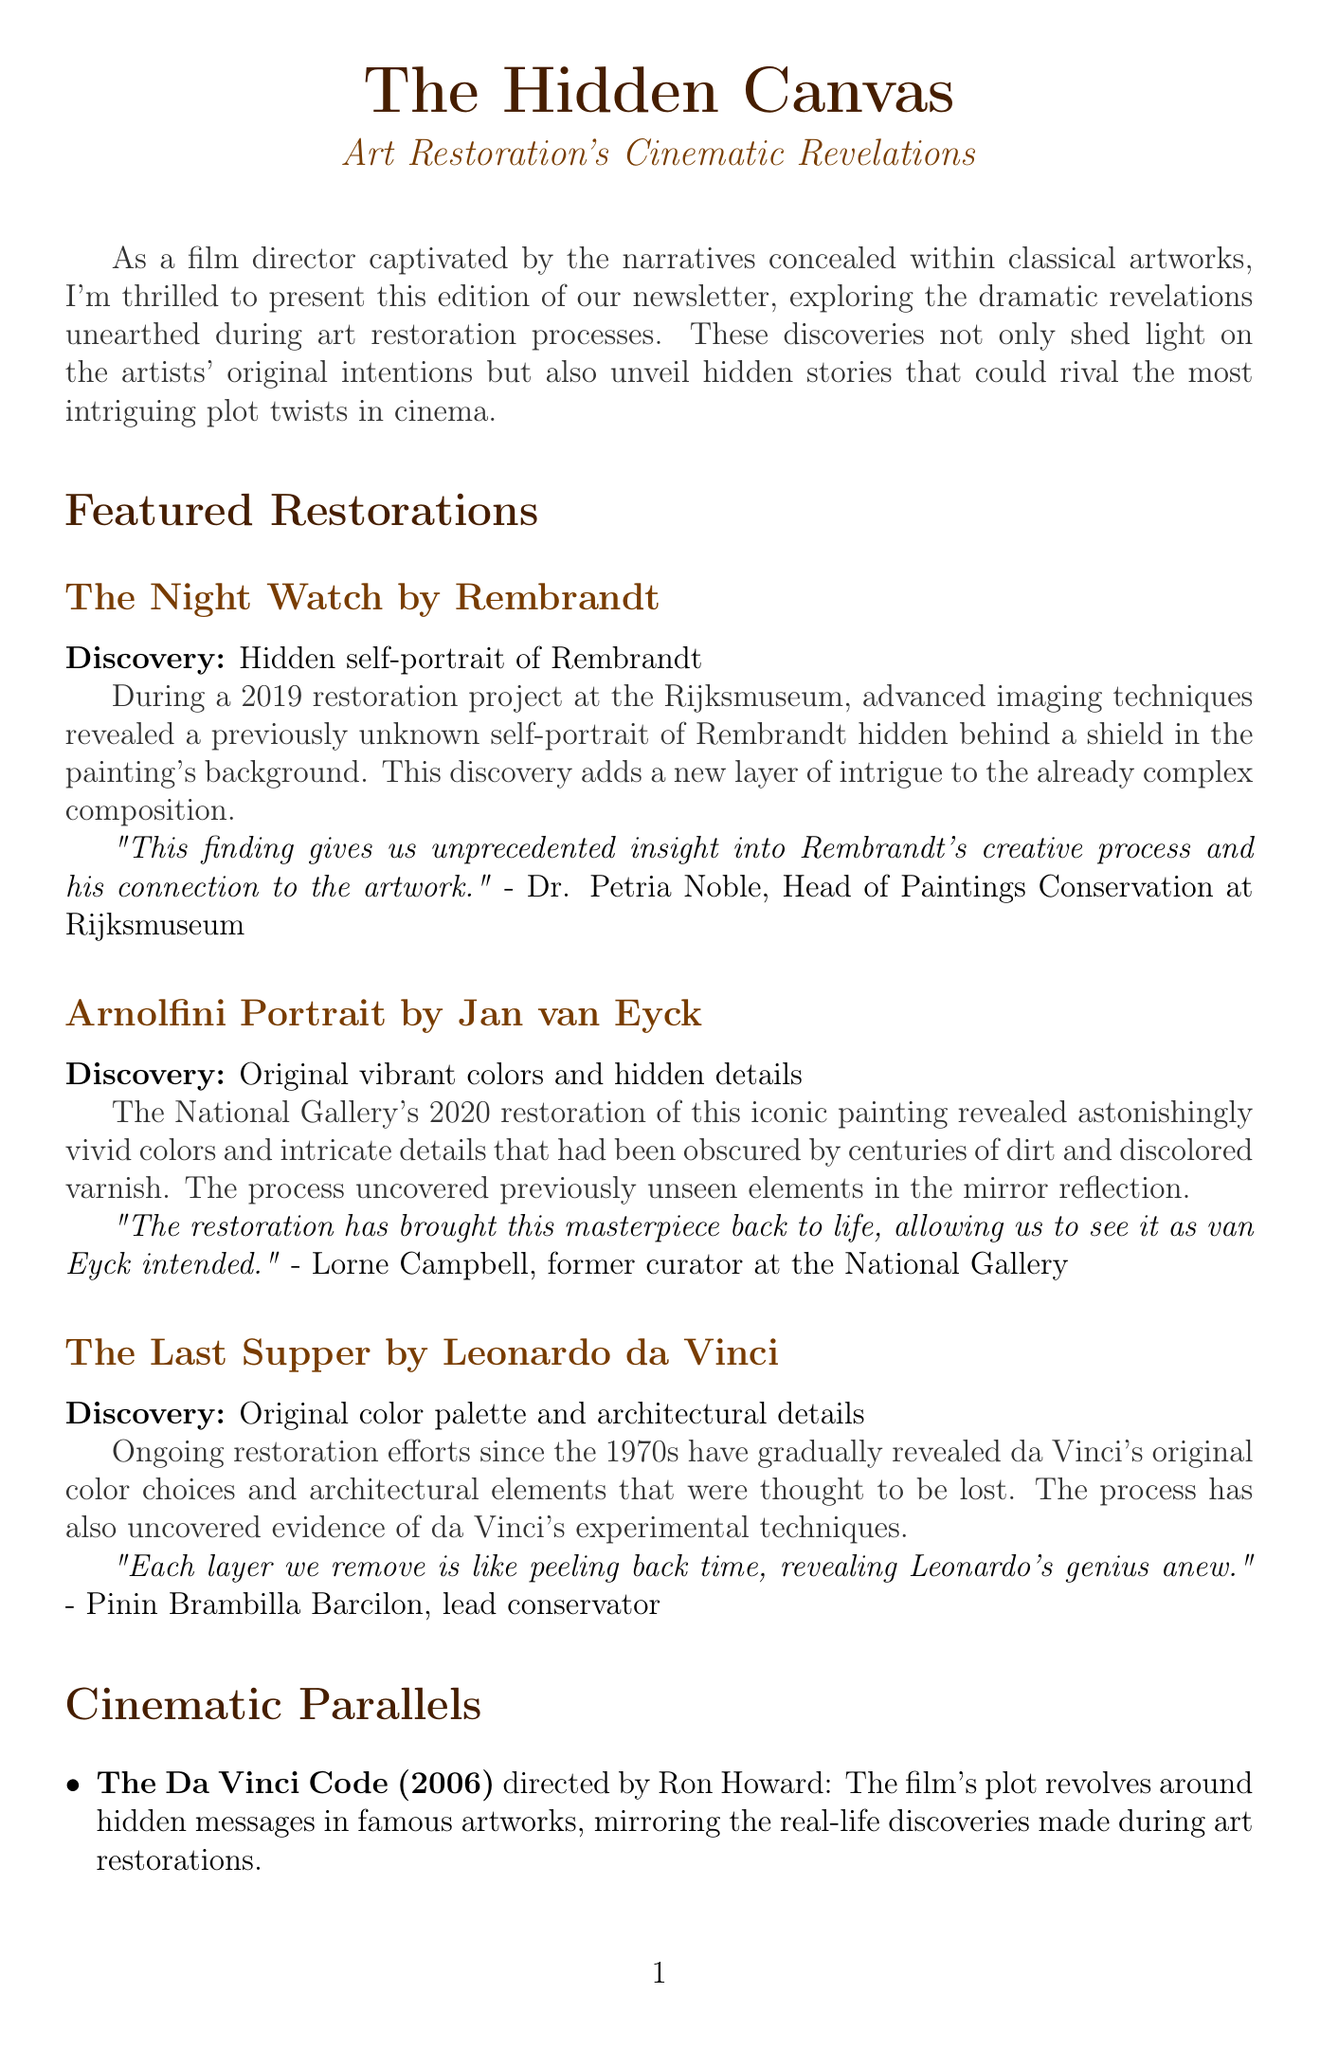What is the title of the newsletter? The title of the newsletter is prominently displayed at the top of the document.
Answer: The Hidden Canvas Who conducted the restoration of The Night Watch? The restoration of The Night Watch was conducted at the Rijksmuseum, which is mentioned in the details.
Answer: Rijksmuseum What year was the Arnolfini Portrait restoration completed? The document provides the year of restoration for this specific painting.
Answer: 2020 What did the restoration of The Last Supper reveal? The document notes significant findings related to da Vinci's original techniques and elements in the painting.
Answer: Original color palette and architectural details Who is quoted regarding the restoration of The Night Watch? The expert commentary section includes quotes from specific experts who discussed the restorations.
Answer: Dr. Petria Noble Which film parallels the discoveries made in art restorations? The document lists films that resemble the themes of art restoration through their plots.
Answer: The Da Vinci Code What is expected to be revealed in the upcoming restoration of Guernica? The document talks about anticipated discoveries that may arise during future restoration projects.
Answer: Possible hidden symbols and underlying sketches related to the Spanish Civil War Who is the interviewee in the document? The document features an interview with a notable figure in both art and film.
Answer: Julian Schnabel What artistic technique did Lorne Campbell associate with the Arnolfini Portrait restoration? The quote highlights the effect of the restoration process on the presentation of the artwork.
Answer: Bringing this masterpiece back to life 